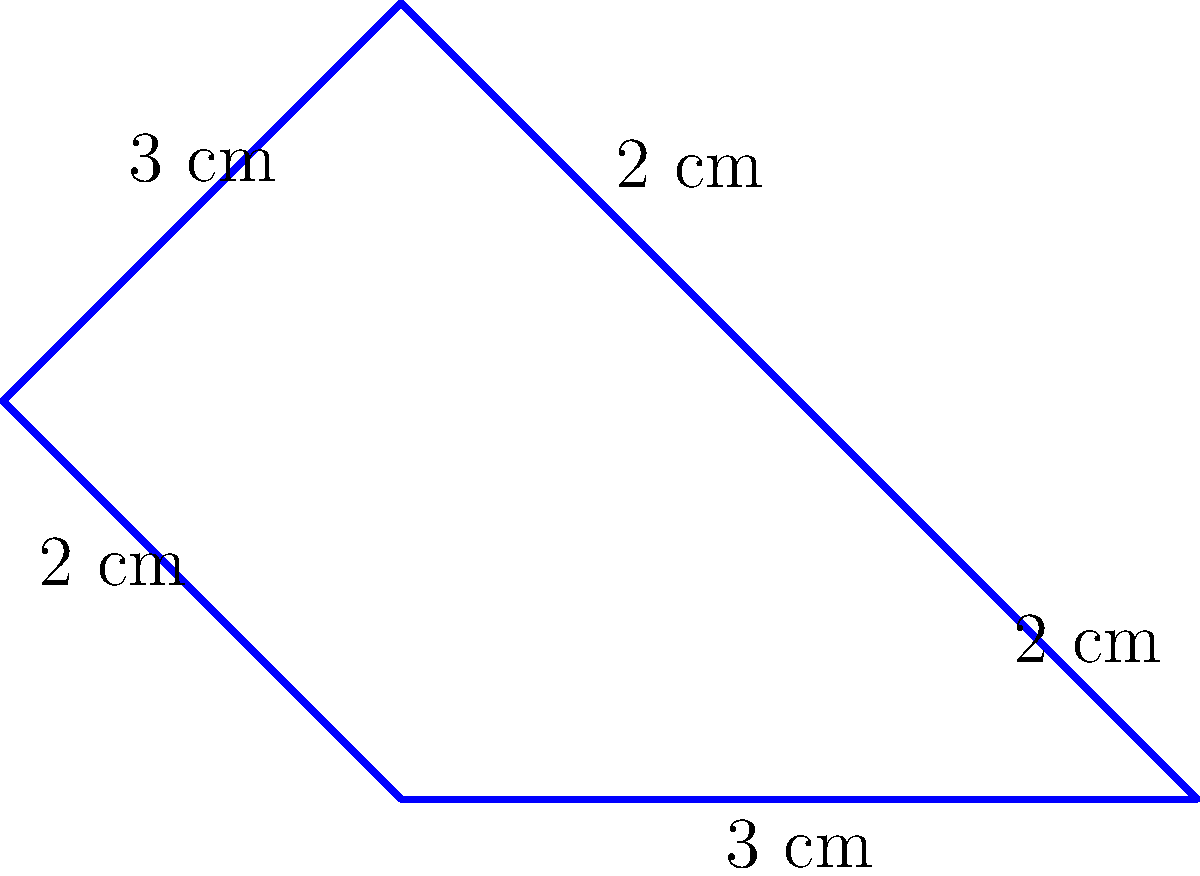In your latest ASMR stream, you're using a star-shaped relaxation symbol to help viewers unwind. The star has five sides with lengths as shown in the diagram. What is the perimeter of this soothing star symbol in centimeters? To find the perimeter of the star-shaped relaxation symbol, we need to add up the lengths of all its sides. Let's break it down step-by-step:

1. Identify the lengths of each side:
   - Two sides are 3 cm long
   - Three sides are 2 cm long

2. Add up all the side lengths:
   $$ \text{Perimeter} = 3 \text{ cm} + 2 \text{ cm} + 2 \text{ cm} + 3 \text{ cm} + 2 \text{ cm} $$

3. Simplify the addition:
   $$ \text{Perimeter} = 12 \text{ cm} $$

Therefore, the perimeter of the star-shaped relaxation symbol is 12 cm.
Answer: 12 cm 